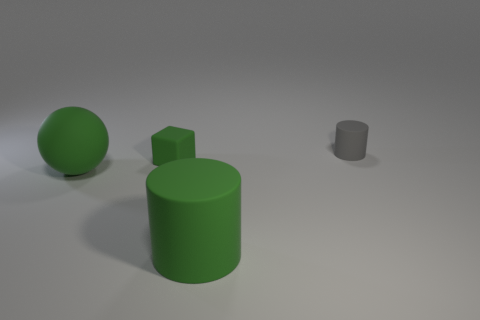Add 1 green rubber spheres. How many objects exist? 5 Subtract all cubes. How many objects are left? 3 Subtract 0 brown balls. How many objects are left? 4 Subtract all tiny green blocks. Subtract all tiny rubber balls. How many objects are left? 3 Add 1 small things. How many small things are left? 3 Add 4 large red matte cylinders. How many large red matte cylinders exist? 4 